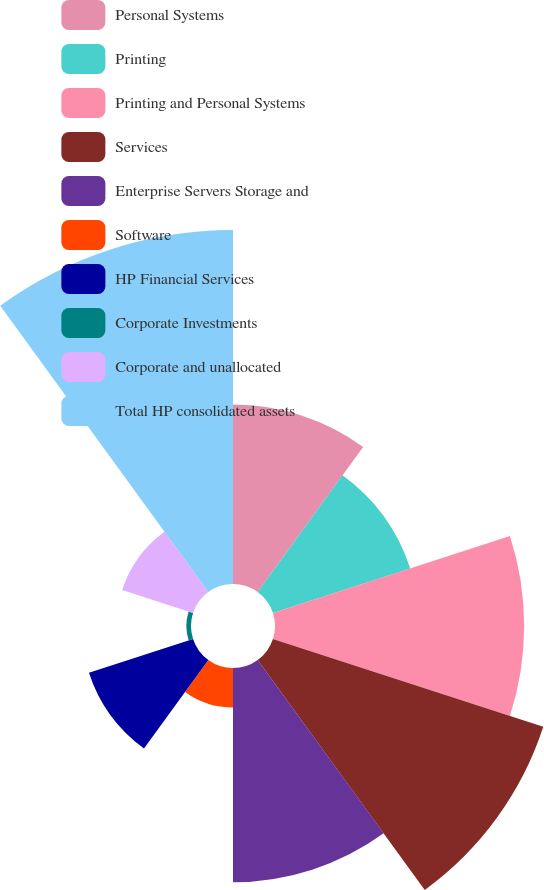Convert chart. <chart><loc_0><loc_0><loc_500><loc_500><pie_chart><fcel>Personal Systems<fcel>Printing<fcel>Printing and Personal Systems<fcel>Services<fcel>Enterprise Servers Storage and<fcel>Software<fcel>HP Financial Services<fcel>Corporate Investments<fcel>Corporate and unallocated<fcel>Total HP consolidated assets<nl><fcel>10.85%<fcel>8.73%<fcel>15.07%<fcel>17.19%<fcel>12.96%<fcel>2.39%<fcel>6.62%<fcel>0.28%<fcel>4.51%<fcel>21.41%<nl></chart> 